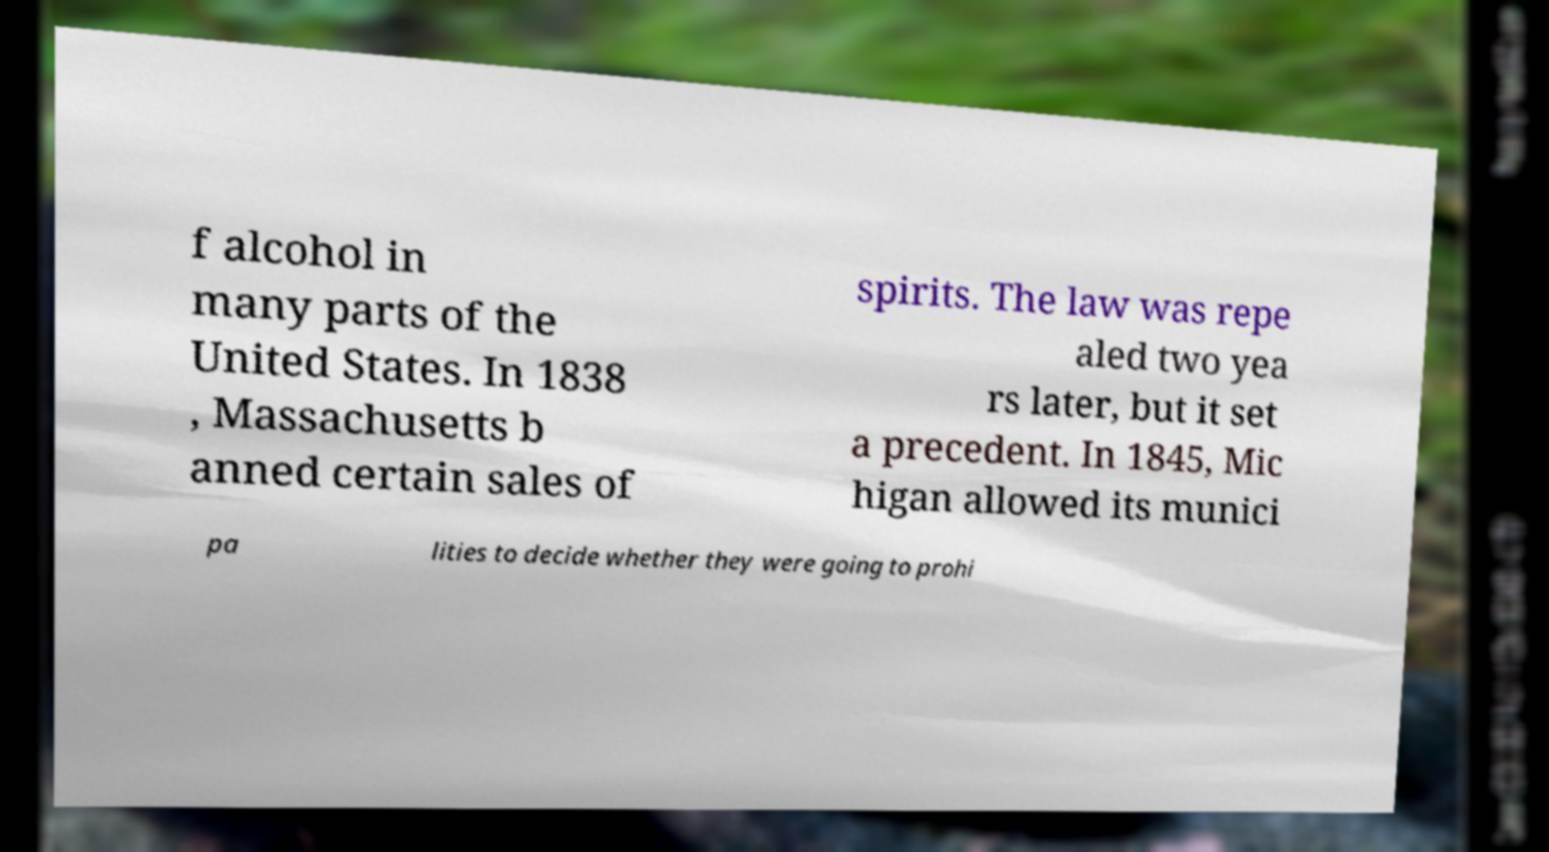Can you accurately transcribe the text from the provided image for me? f alcohol in many parts of the United States. In 1838 , Massachusetts b anned certain sales of spirits. The law was repe aled two yea rs later, but it set a precedent. In 1845, Mic higan allowed its munici pa lities to decide whether they were going to prohi 